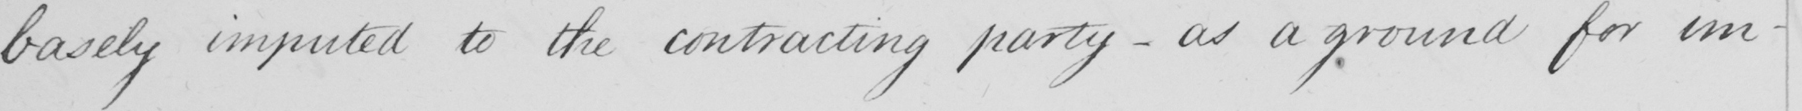Can you read and transcribe this handwriting? basely imputed to the contracting party  _  as a ground for im- 